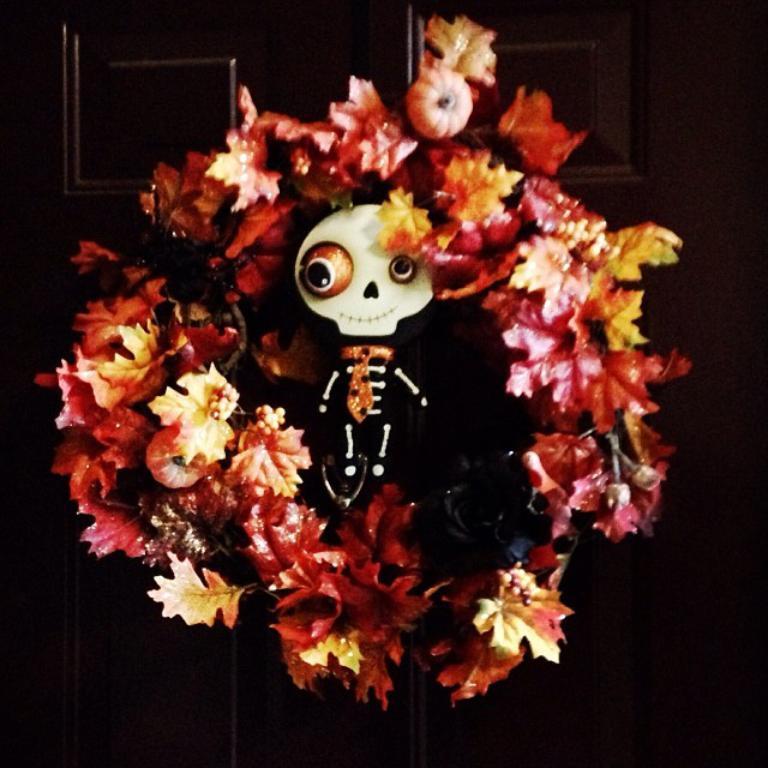Describe this image in one or two sentences. In this image there are flowers. In between the flowers there is a skeleton with skull. In the background of the image there is a wooden board. 